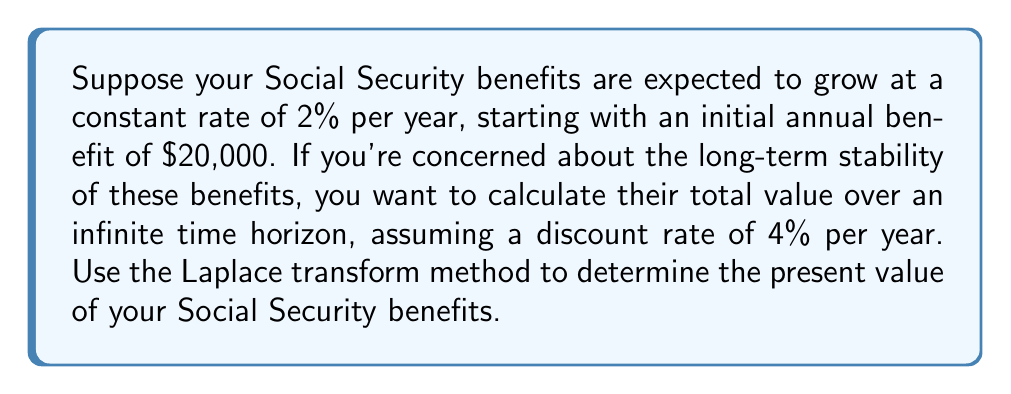Could you help me with this problem? Let's approach this step-by-step using Laplace transforms:

1) First, let's define our function. The benefit at time t can be expressed as:
   
   $f(t) = 20000 \cdot e^{0.02t}$

2) The present value of a future cash flow is given by:
   
   $PV = \int_0^\infty f(t) \cdot e^{-rt} dt$

   where r is the discount rate (4% = 0.04 in this case)

3) This integral is in the form of a Laplace transform. Recall that the Laplace transform is defined as:

   $\mathcal{L}\{f(t)\} = F(s) = \int_0^\infty f(t) \cdot e^{-st} dt$

4) In our case, s = r = 0.04, and we need to find:

   $\mathcal{L}\{20000 \cdot e^{0.02t}\}|_{s=0.04}$

5) We can use the Laplace transform property for exponential functions:

   $\mathcal{L}\{e^{at}\} = \frac{1}{s-a}$

6) Applying this to our problem:

   $\mathcal{L}\{20000 \cdot e^{0.02t}\} = \frac{20000}{s-0.02}$

7) Now, we evaluate this at s = 0.04:

   $PV = \frac{20000}{0.04-0.02} = \frac{20000}{0.02} = 1000000$

Therefore, the present value of the Social Security benefits over an infinite time horizon is $1,000,000.
Answer: $1,000,000 